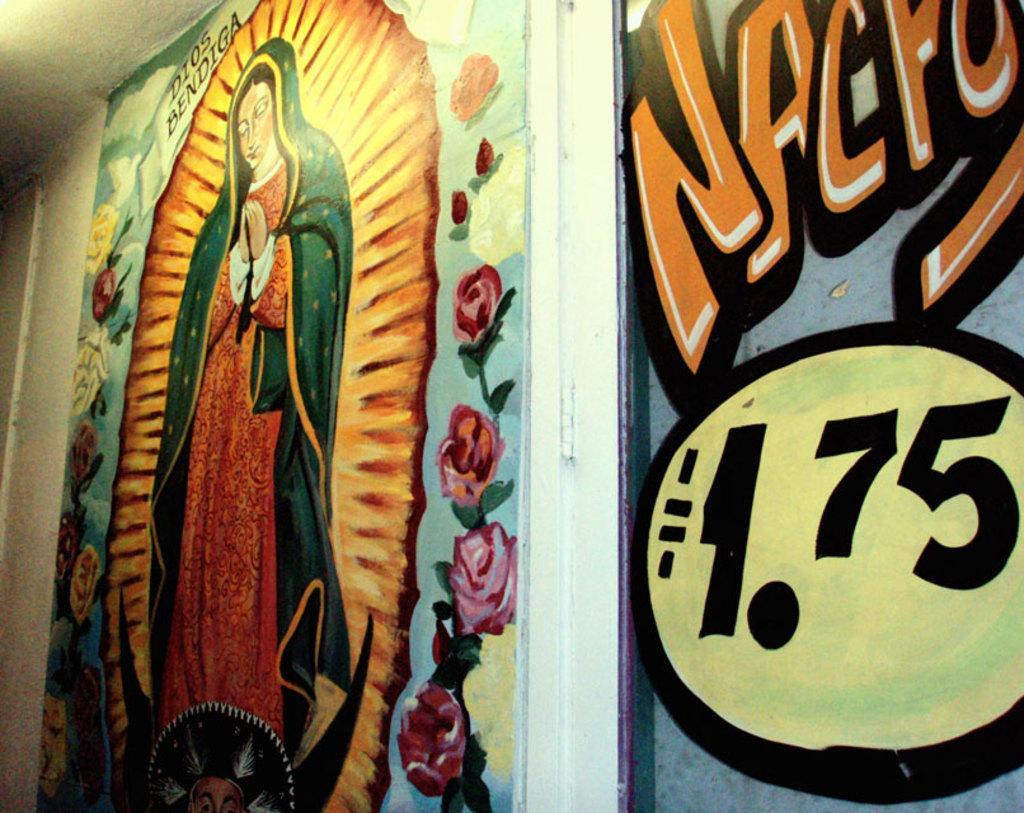Please provide a concise description of this image. On the left side of the image we can see a painting on the wall of a lady. On the right side of the image we can see a painting on a wall of some text. 